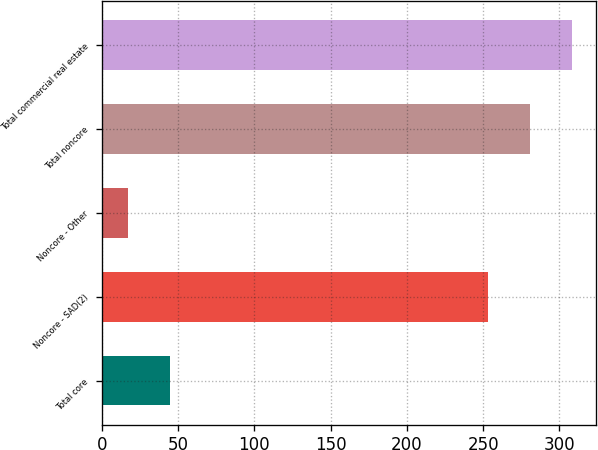Convert chart. <chart><loc_0><loc_0><loc_500><loc_500><bar_chart><fcel>Total core<fcel>Noncore - SAD(2)<fcel>Noncore - Other<fcel>Total noncore<fcel>Total commercial real estate<nl><fcel>44.8<fcel>253<fcel>17<fcel>280.8<fcel>308.6<nl></chart> 